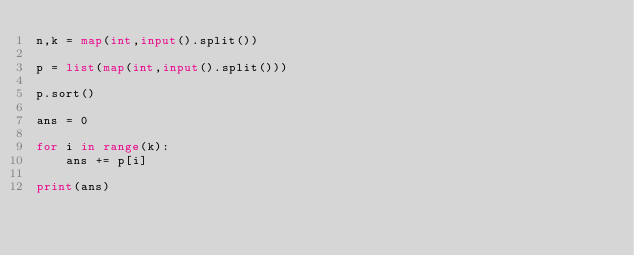Convert code to text. <code><loc_0><loc_0><loc_500><loc_500><_Python_>n,k = map(int,input().split())

p = list(map(int,input().split()))

p.sort()

ans = 0

for i in range(k):
    ans += p[i]
    
print(ans)</code> 